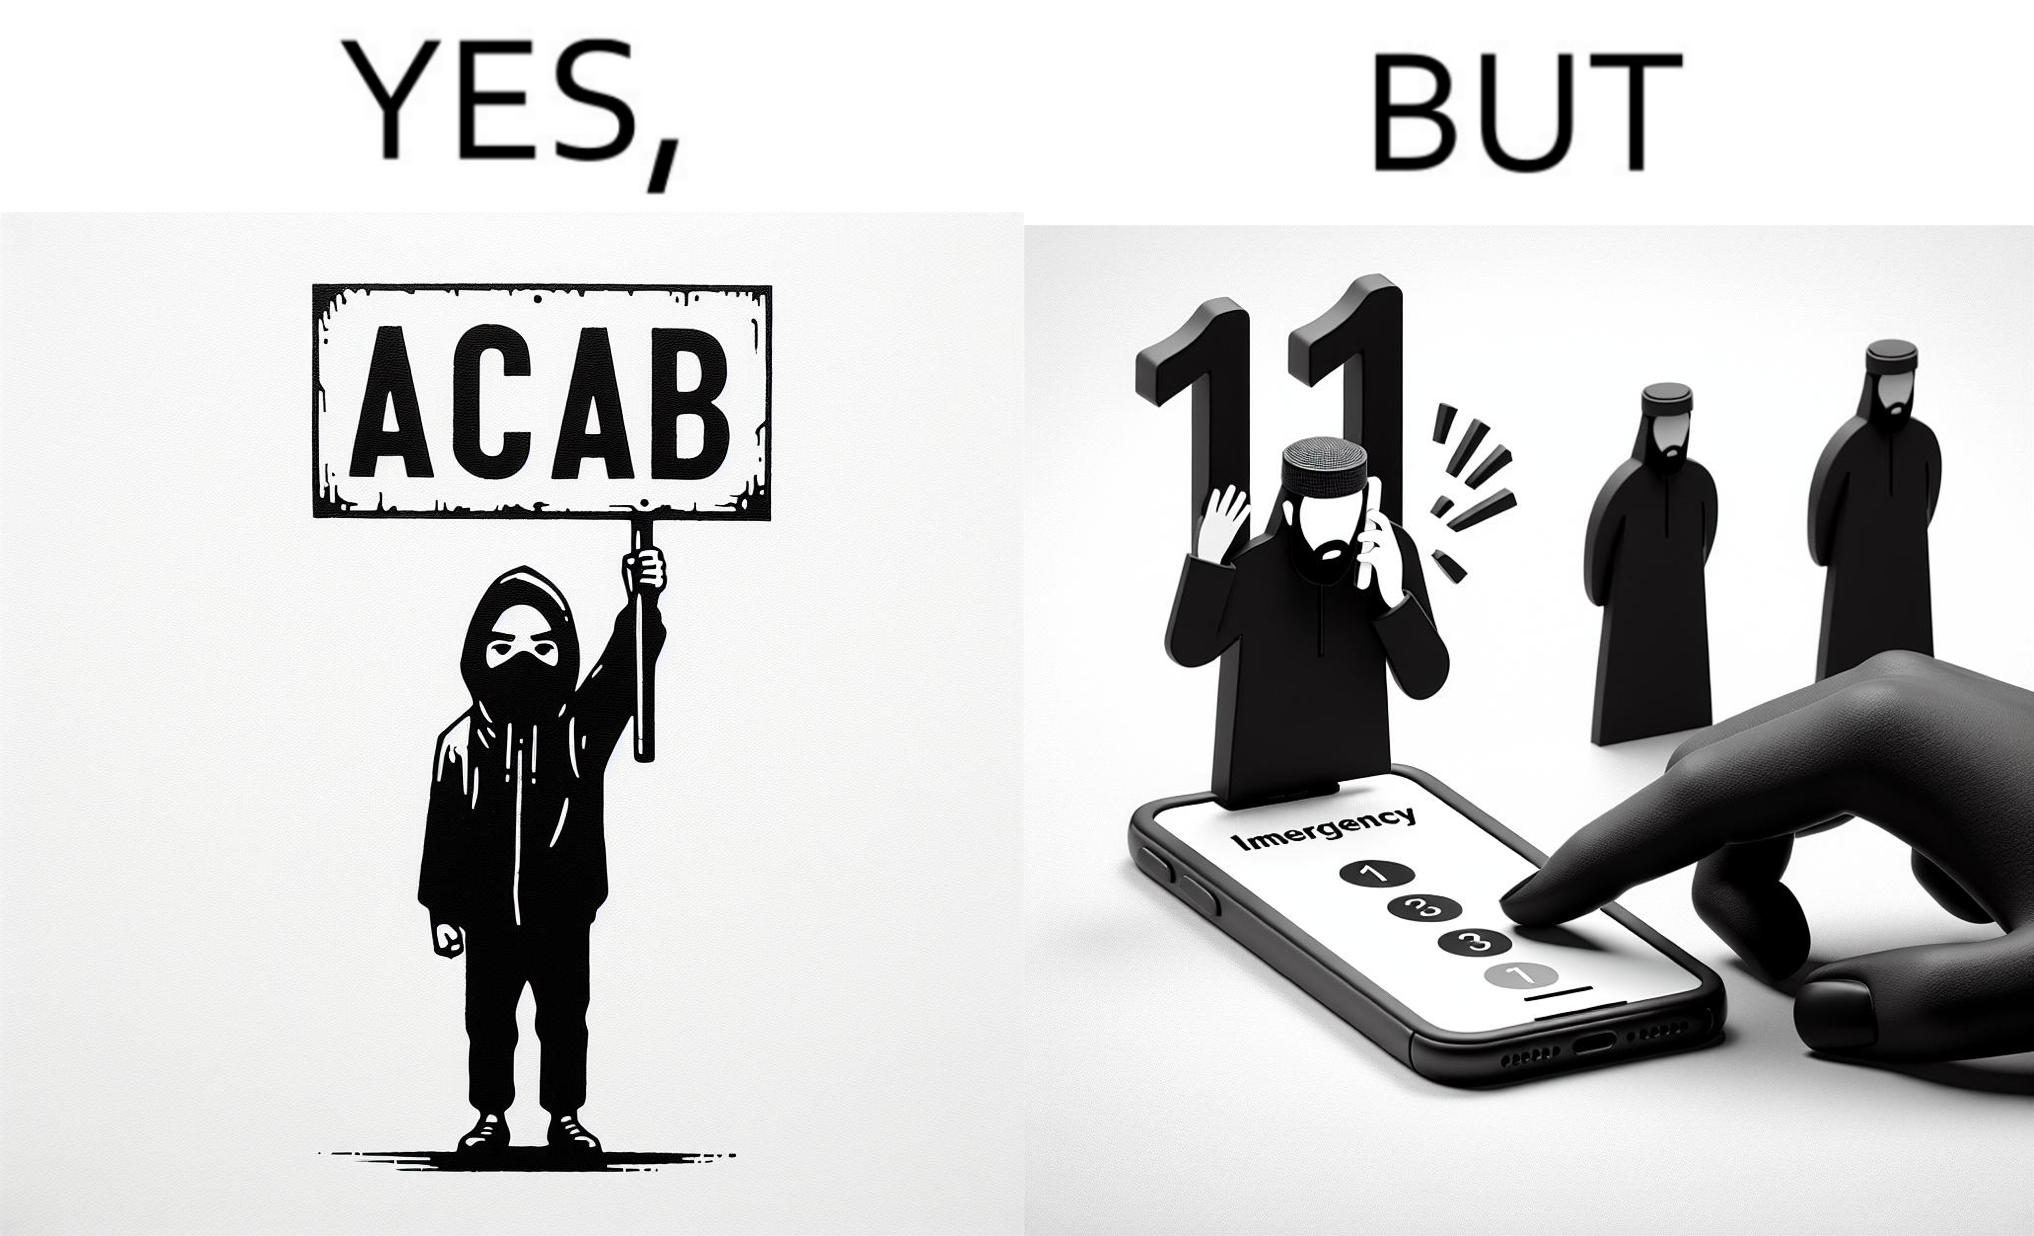What do you see in each half of this image? In the left part of the image: A person holding a sign that says the letters ACAB. The persons face is covered by a mask, they have black nails and they looks like they are protesting something. In the right part of the image: Person dialling 112 Emergency number on their phone. They have black nails 